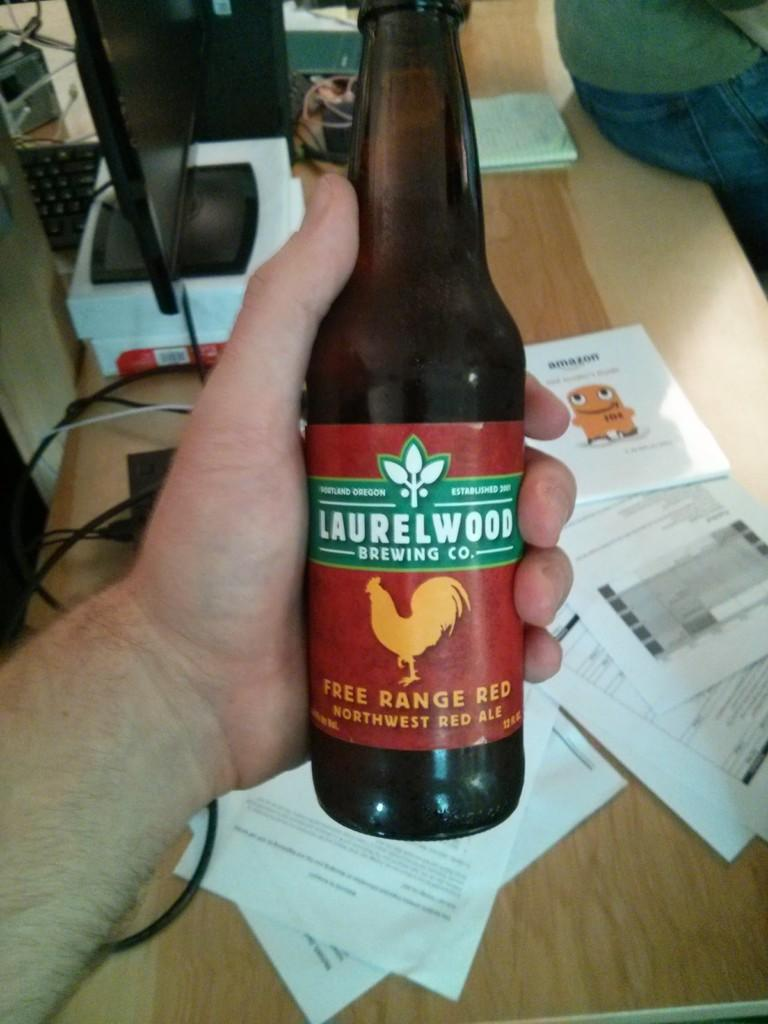<image>
Summarize the visual content of the image. A man is holding a bottle of beer called Free Range Red from Laurelwood Brewing Co. above a desk scattered with paper. 